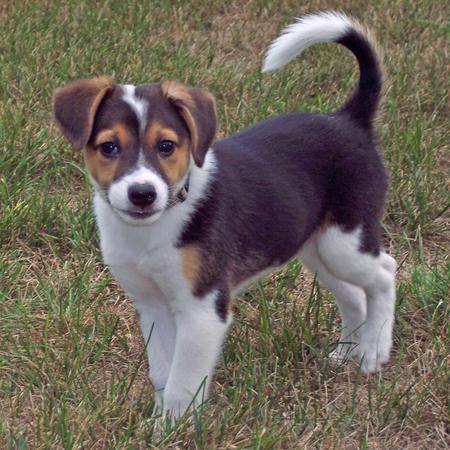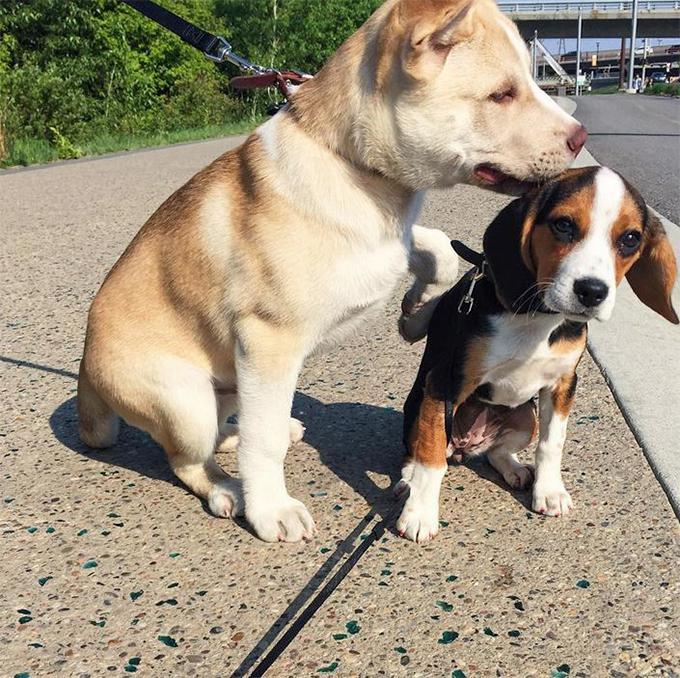The first image is the image on the left, the second image is the image on the right. For the images shown, is this caption "At least one dog is one a leash in one of the images." true? Answer yes or no. Yes. The first image is the image on the left, the second image is the image on the right. For the images displayed, is the sentence "At least one of the dogs is inside." factually correct? Answer yes or no. No. 